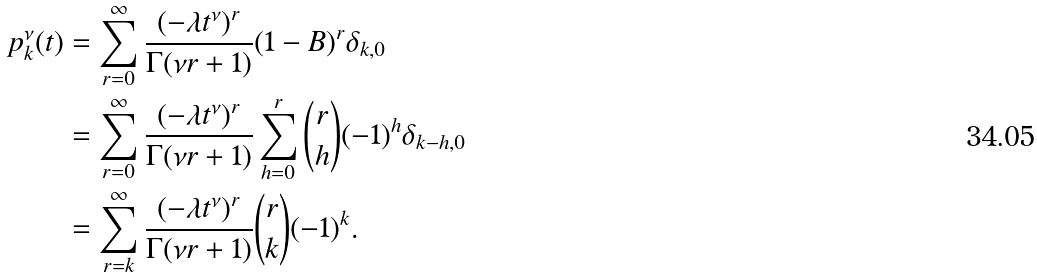<formula> <loc_0><loc_0><loc_500><loc_500>p _ { k } ^ { \nu } ( t ) & = \sum _ { r = 0 } ^ { \infty } \frac { ( - \lambda t ^ { \nu } ) ^ { r } } { \Gamma ( \nu r + 1 ) } ( 1 - B ) ^ { r } \delta _ { k , 0 } \\ & = \sum _ { r = 0 } ^ { \infty } \frac { ( - \lambda t ^ { \nu } ) ^ { r } } { \Gamma ( \nu r + 1 ) } \sum _ { h = 0 } ^ { r } \binom { r } { h } ( - 1 ) ^ { h } \delta _ { k - h , 0 } \\ & = \sum _ { r = k } ^ { \infty } \frac { ( - \lambda t ^ { \nu } ) ^ { r } } { \Gamma ( \nu r + 1 ) } \binom { r } { k } ( - 1 ) ^ { k } .</formula> 